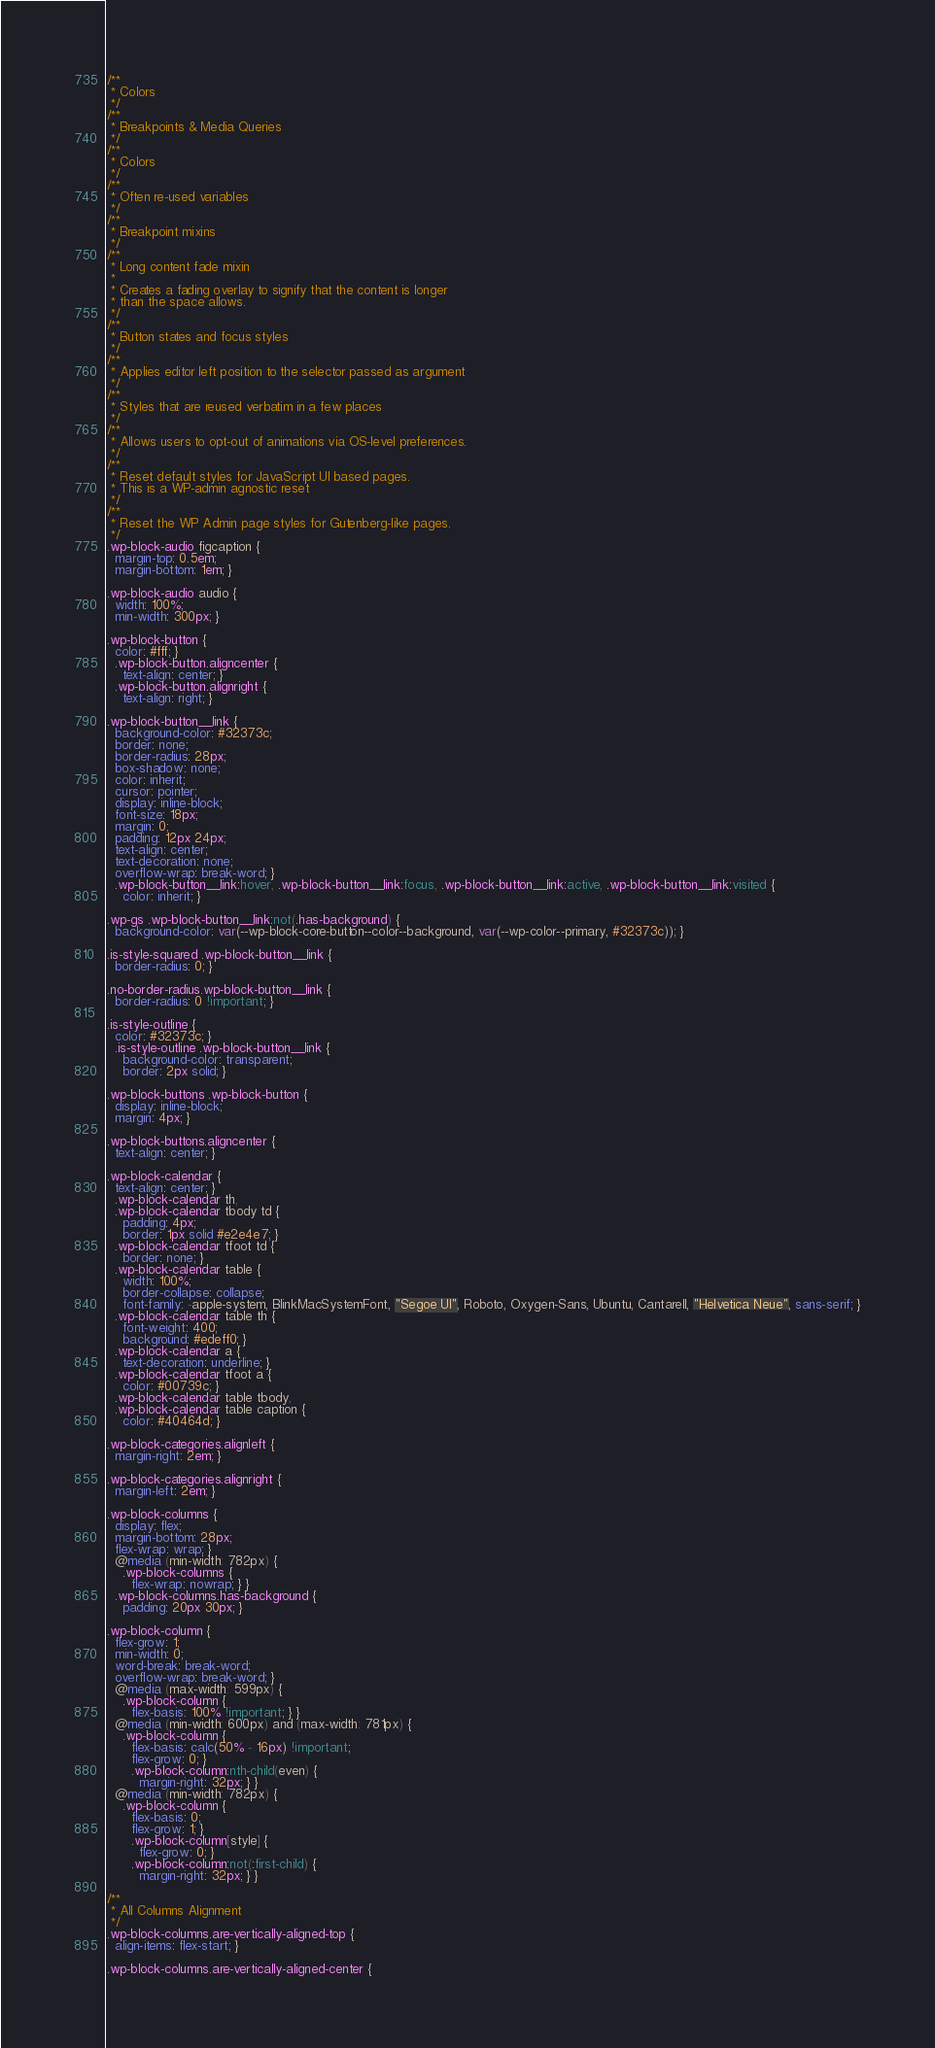<code> <loc_0><loc_0><loc_500><loc_500><_CSS_>/**
 * Colors
 */
/**
 * Breakpoints & Media Queries
 */
/**
 * Colors
 */
/**
 * Often re-used variables
 */
/**
 * Breakpoint mixins
 */
/**
 * Long content fade mixin
 *
 * Creates a fading overlay to signify that the content is longer
 * than the space allows.
 */
/**
 * Button states and focus styles
 */
/**
 * Applies editor left position to the selector passed as argument
 */
/**
 * Styles that are reused verbatim in a few places
 */
/**
 * Allows users to opt-out of animations via OS-level preferences.
 */
/**
 * Reset default styles for JavaScript UI based pages.
 * This is a WP-admin agnostic reset
 */
/**
 * Reset the WP Admin page styles for Gutenberg-like pages.
 */
.wp-block-audio figcaption {
  margin-top: 0.5em;
  margin-bottom: 1em; }

.wp-block-audio audio {
  width: 100%;
  min-width: 300px; }

.wp-block-button {
  color: #fff; }
  .wp-block-button.aligncenter {
    text-align: center; }
  .wp-block-button.alignright {
    text-align: right; }

.wp-block-button__link {
  background-color: #32373c;
  border: none;
  border-radius: 28px;
  box-shadow: none;
  color: inherit;
  cursor: pointer;
  display: inline-block;
  font-size: 18px;
  margin: 0;
  padding: 12px 24px;
  text-align: center;
  text-decoration: none;
  overflow-wrap: break-word; }
  .wp-block-button__link:hover, .wp-block-button__link:focus, .wp-block-button__link:active, .wp-block-button__link:visited {
    color: inherit; }

.wp-gs .wp-block-button__link:not(.has-background) {
  background-color: var(--wp-block-core-button--color--background, var(--wp-color--primary, #32373c)); }

.is-style-squared .wp-block-button__link {
  border-radius: 0; }

.no-border-radius.wp-block-button__link {
  border-radius: 0 !important; }

.is-style-outline {
  color: #32373c; }
  .is-style-outline .wp-block-button__link {
    background-color: transparent;
    border: 2px solid; }

.wp-block-buttons .wp-block-button {
  display: inline-block;
  margin: 4px; }

.wp-block-buttons.aligncenter {
  text-align: center; }

.wp-block-calendar {
  text-align: center; }
  .wp-block-calendar th,
  .wp-block-calendar tbody td {
    padding: 4px;
    border: 1px solid #e2e4e7; }
  .wp-block-calendar tfoot td {
    border: none; }
  .wp-block-calendar table {
    width: 100%;
    border-collapse: collapse;
    font-family: -apple-system, BlinkMacSystemFont, "Segoe UI", Roboto, Oxygen-Sans, Ubuntu, Cantarell, "Helvetica Neue", sans-serif; }
  .wp-block-calendar table th {
    font-weight: 400;
    background: #edeff0; }
  .wp-block-calendar a {
    text-decoration: underline; }
  .wp-block-calendar tfoot a {
    color: #00739c; }
  .wp-block-calendar table tbody,
  .wp-block-calendar table caption {
    color: #40464d; }

.wp-block-categories.alignleft {
  margin-right: 2em; }

.wp-block-categories.alignright {
  margin-left: 2em; }

.wp-block-columns {
  display: flex;
  margin-bottom: 28px;
  flex-wrap: wrap; }
  @media (min-width: 782px) {
    .wp-block-columns {
      flex-wrap: nowrap; } }
  .wp-block-columns.has-background {
    padding: 20px 30px; }

.wp-block-column {
  flex-grow: 1;
  min-width: 0;
  word-break: break-word;
  overflow-wrap: break-word; }
  @media (max-width: 599px) {
    .wp-block-column {
      flex-basis: 100% !important; } }
  @media (min-width: 600px) and (max-width: 781px) {
    .wp-block-column {
      flex-basis: calc(50% - 16px) !important;
      flex-grow: 0; }
      .wp-block-column:nth-child(even) {
        margin-right: 32px; } }
  @media (min-width: 782px) {
    .wp-block-column {
      flex-basis: 0;
      flex-grow: 1; }
      .wp-block-column[style] {
        flex-grow: 0; }
      .wp-block-column:not(:first-child) {
        margin-right: 32px; } }

/**
 * All Columns Alignment
 */
.wp-block-columns.are-vertically-aligned-top {
  align-items: flex-start; }

.wp-block-columns.are-vertically-aligned-center {</code> 